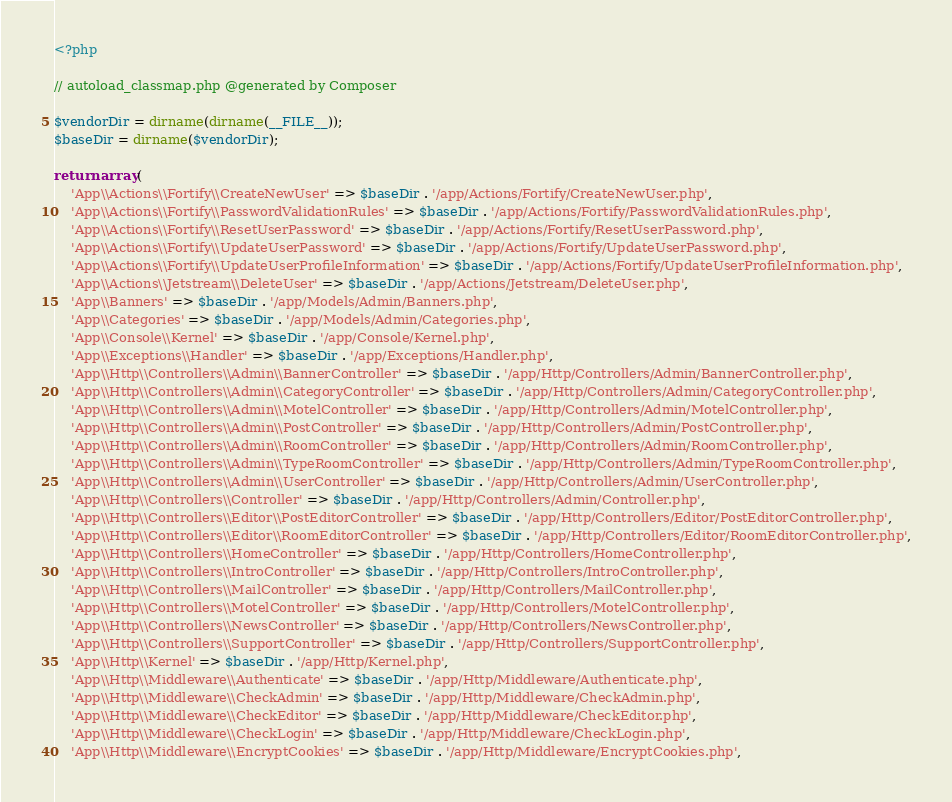<code> <loc_0><loc_0><loc_500><loc_500><_PHP_><?php

// autoload_classmap.php @generated by Composer

$vendorDir = dirname(dirname(__FILE__));
$baseDir = dirname($vendorDir);

return array(
    'App\\Actions\\Fortify\\CreateNewUser' => $baseDir . '/app/Actions/Fortify/CreateNewUser.php',
    'App\\Actions\\Fortify\\PasswordValidationRules' => $baseDir . '/app/Actions/Fortify/PasswordValidationRules.php',
    'App\\Actions\\Fortify\\ResetUserPassword' => $baseDir . '/app/Actions/Fortify/ResetUserPassword.php',
    'App\\Actions\\Fortify\\UpdateUserPassword' => $baseDir . '/app/Actions/Fortify/UpdateUserPassword.php',
    'App\\Actions\\Fortify\\UpdateUserProfileInformation' => $baseDir . '/app/Actions/Fortify/UpdateUserProfileInformation.php',
    'App\\Actions\\Jetstream\\DeleteUser' => $baseDir . '/app/Actions/Jetstream/DeleteUser.php',
    'App\\Banners' => $baseDir . '/app/Models/Admin/Banners.php',
    'App\\Categories' => $baseDir . '/app/Models/Admin/Categories.php',
    'App\\Console\\Kernel' => $baseDir . '/app/Console/Kernel.php',
    'App\\Exceptions\\Handler' => $baseDir . '/app/Exceptions/Handler.php',
    'App\\Http\\Controllers\\Admin\\BannerController' => $baseDir . '/app/Http/Controllers/Admin/BannerController.php',
    'App\\Http\\Controllers\\Admin\\CategoryController' => $baseDir . '/app/Http/Controllers/Admin/CategoryController.php',
    'App\\Http\\Controllers\\Admin\\MotelController' => $baseDir . '/app/Http/Controllers/Admin/MotelController.php',
    'App\\Http\\Controllers\\Admin\\PostController' => $baseDir . '/app/Http/Controllers/Admin/PostController.php',
    'App\\Http\\Controllers\\Admin\\RoomController' => $baseDir . '/app/Http/Controllers/Admin/RoomController.php',
    'App\\Http\\Controllers\\Admin\\TypeRoomController' => $baseDir . '/app/Http/Controllers/Admin/TypeRoomController.php',
    'App\\Http\\Controllers\\Admin\\UserController' => $baseDir . '/app/Http/Controllers/Admin/UserController.php',
    'App\\Http\\Controllers\\Controller' => $baseDir . '/app/Http/Controllers/Admin/Controller.php',
    'App\\Http\\Controllers\\Editor\\PostEditorController' => $baseDir . '/app/Http/Controllers/Editor/PostEditorController.php',
    'App\\Http\\Controllers\\Editor\\RoomEditorController' => $baseDir . '/app/Http/Controllers/Editor/RoomEditorController.php',
    'App\\Http\\Controllers\\HomeController' => $baseDir . '/app/Http/Controllers/HomeController.php',
    'App\\Http\\Controllers\\IntroController' => $baseDir . '/app/Http/Controllers/IntroController.php',
    'App\\Http\\Controllers\\MailController' => $baseDir . '/app/Http/Controllers/MailController.php',
    'App\\Http\\Controllers\\MotelController' => $baseDir . '/app/Http/Controllers/MotelController.php',
    'App\\Http\\Controllers\\NewsController' => $baseDir . '/app/Http/Controllers/NewsController.php',
    'App\\Http\\Controllers\\SupportController' => $baseDir . '/app/Http/Controllers/SupportController.php',
    'App\\Http\\Kernel' => $baseDir . '/app/Http/Kernel.php',
    'App\\Http\\Middleware\\Authenticate' => $baseDir . '/app/Http/Middleware/Authenticate.php',
    'App\\Http\\Middleware\\CheckAdmin' => $baseDir . '/app/Http/Middleware/CheckAdmin.php',
    'App\\Http\\Middleware\\CheckEditor' => $baseDir . '/app/Http/Middleware/CheckEditor.php',
    'App\\Http\\Middleware\\CheckLogin' => $baseDir . '/app/Http/Middleware/CheckLogin.php',
    'App\\Http\\Middleware\\EncryptCookies' => $baseDir . '/app/Http/Middleware/EncryptCookies.php',</code> 